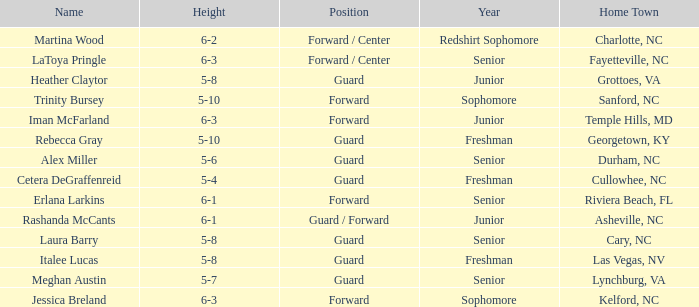In what year of school is the forward Iman McFarland? Junior. 